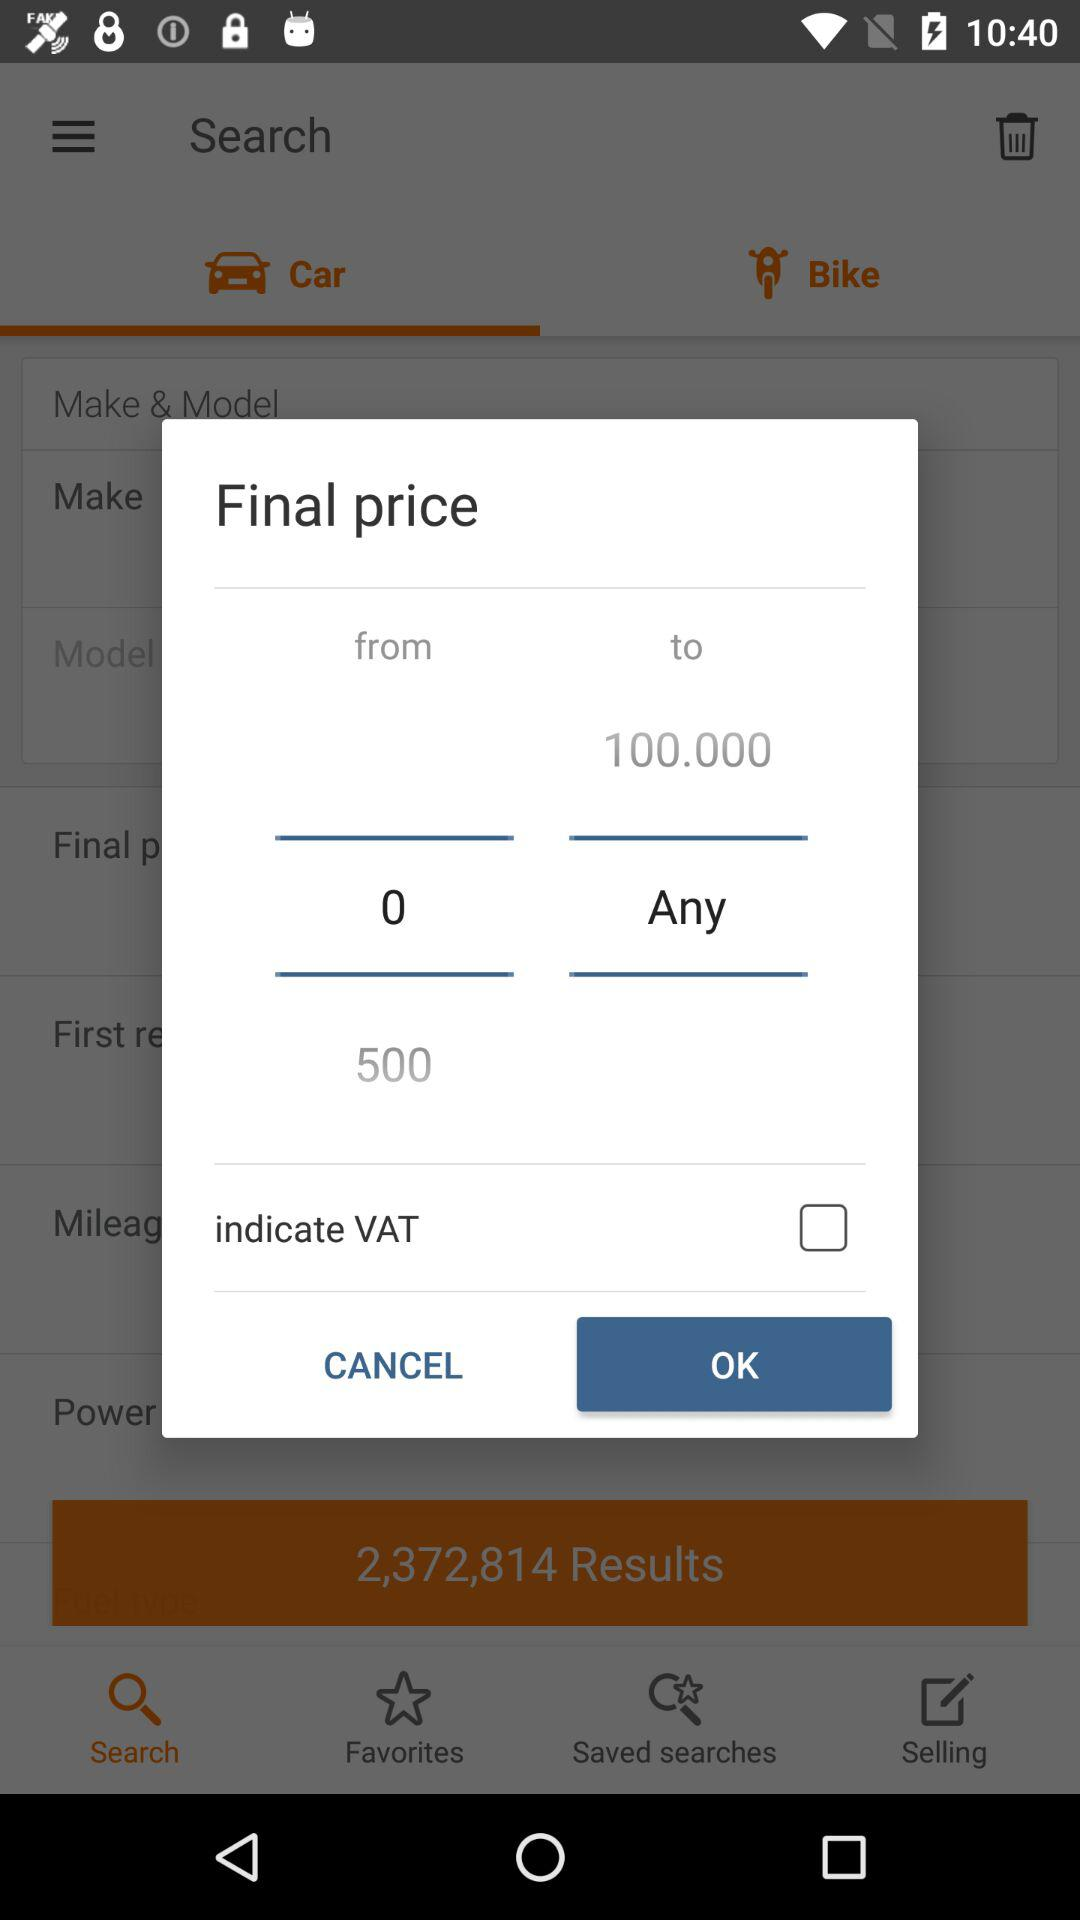What is the final price range? The final price range is "0 to Any". 